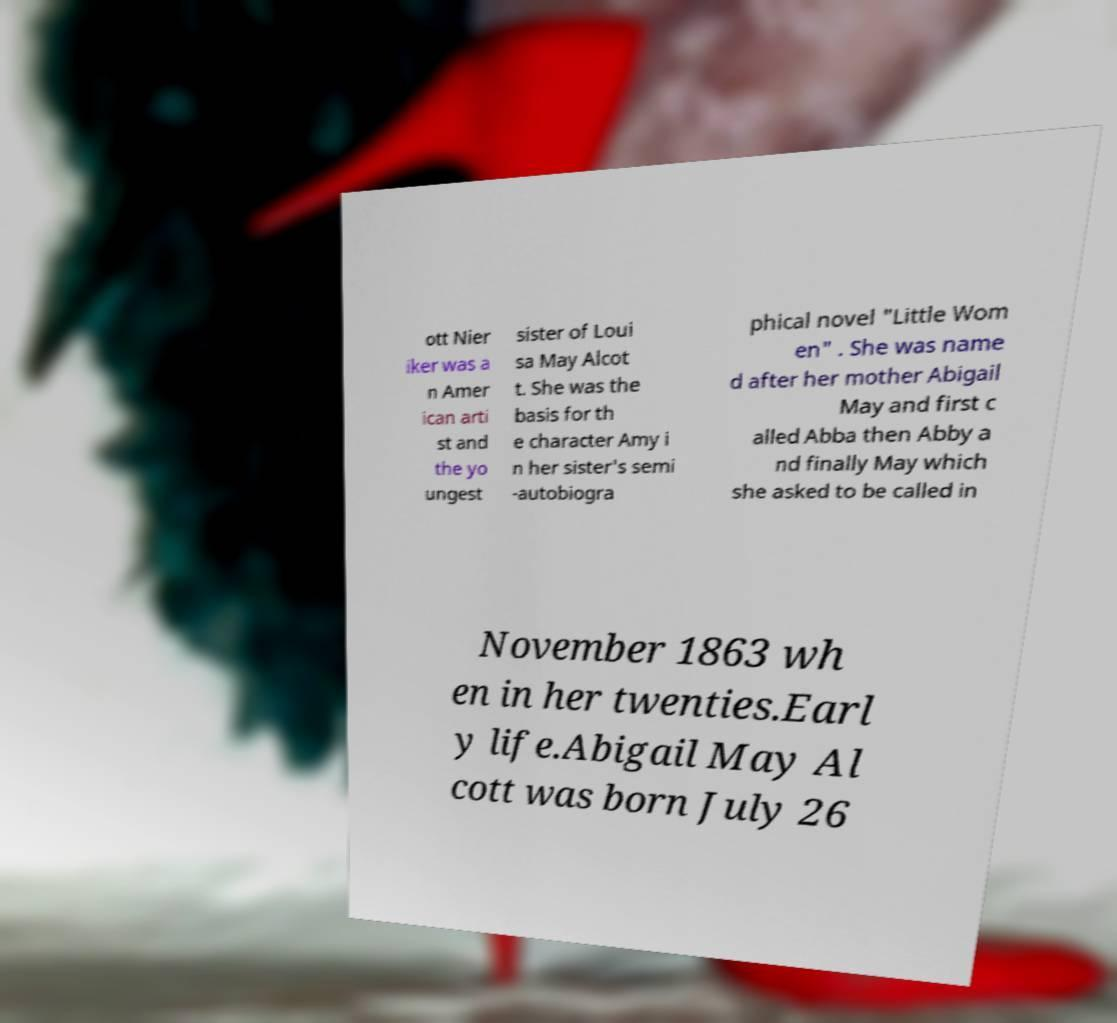There's text embedded in this image that I need extracted. Can you transcribe it verbatim? ott Nier iker was a n Amer ican arti st and the yo ungest sister of Loui sa May Alcot t. She was the basis for th e character Amy i n her sister's semi -autobiogra phical novel "Little Wom en" . She was name d after her mother Abigail May and first c alled Abba then Abby a nd finally May which she asked to be called in November 1863 wh en in her twenties.Earl y life.Abigail May Al cott was born July 26 